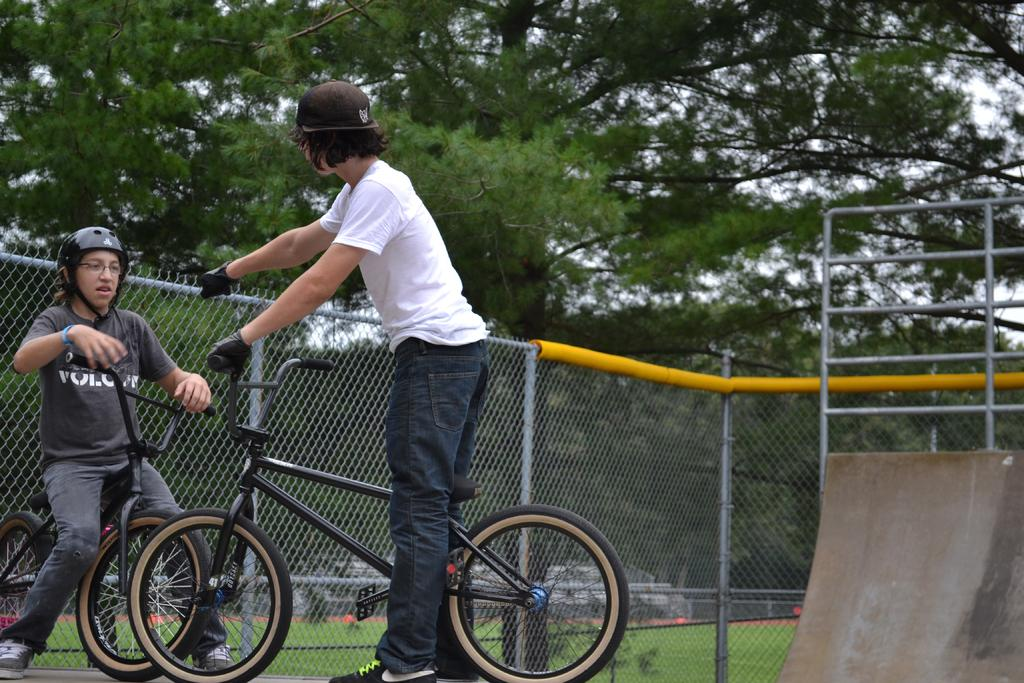How many people are in the image? There are two people in the image. What are the two people doing in the image? The two people are on a bicycle. What safety precautions are the people taking in the image? The people are wearing helmets. What can be seen in the background of the image? There is a fence and trees in the background of the image. What type of butter is being used to grease the bicycle tires in the image? There is no butter present in the image, and the bicycle tires do not require greasing. 